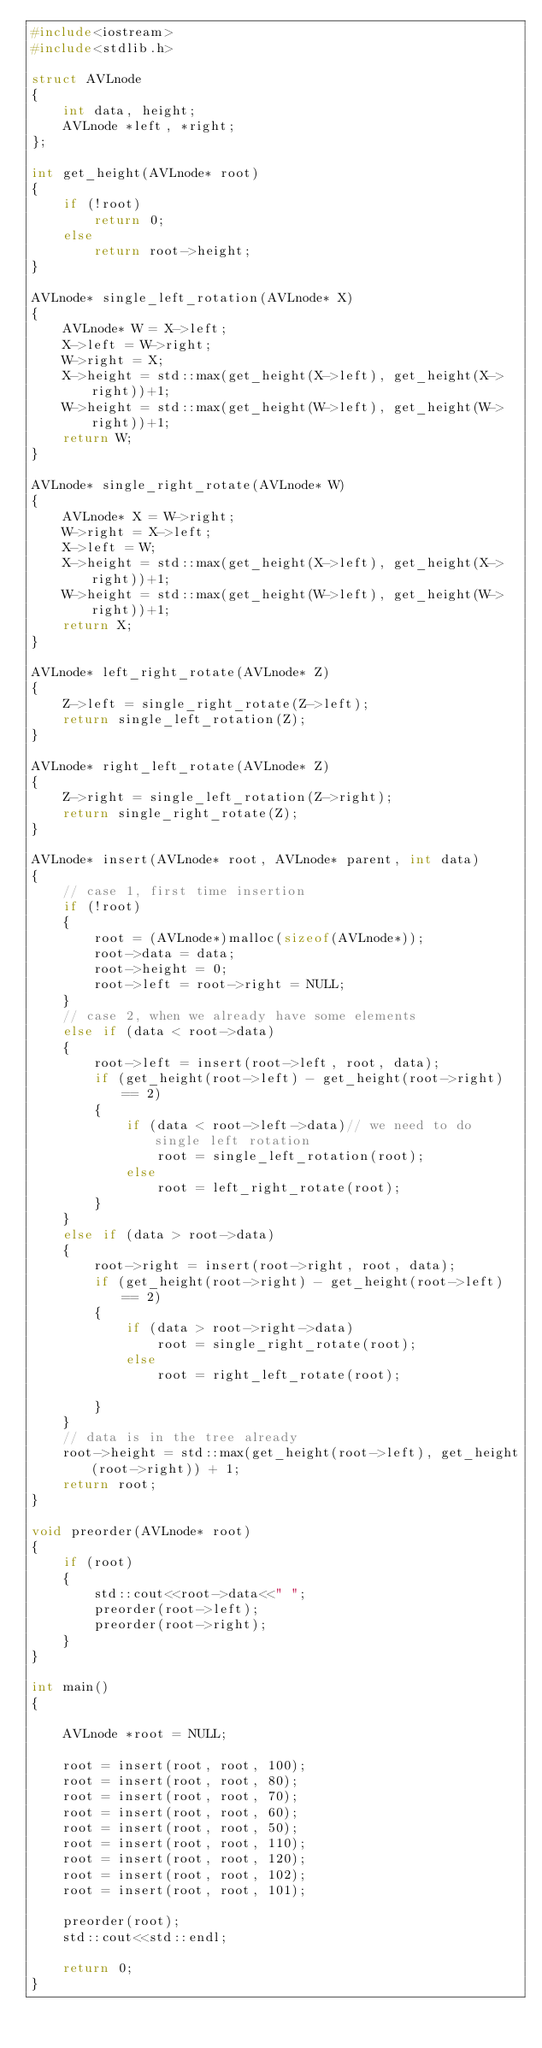Convert code to text. <code><loc_0><loc_0><loc_500><loc_500><_C++_>#include<iostream>
#include<stdlib.h>

struct AVLnode
{
    int data, height;
    AVLnode *left, *right;
};

int get_height(AVLnode* root)
{
    if (!root)
        return 0;
    else
        return root->height;
}

AVLnode* single_left_rotation(AVLnode* X)
{
    AVLnode* W = X->left;
    X->left = W->right;
    W->right = X;
    X->height = std::max(get_height(X->left), get_height(X->right))+1;
    W->height = std::max(get_height(W->left), get_height(W->right))+1;
    return W;
}

AVLnode* single_right_rotate(AVLnode* W)
{
    AVLnode* X = W->right;
    W->right = X->left;
    X->left = W;
    X->height = std::max(get_height(X->left), get_height(X->right))+1;
    W->height = std::max(get_height(W->left), get_height(W->right))+1;
    return X;
}

AVLnode* left_right_rotate(AVLnode* Z)
{
    Z->left = single_right_rotate(Z->left);
    return single_left_rotation(Z);
}

AVLnode* right_left_rotate(AVLnode* Z)
{
    Z->right = single_left_rotation(Z->right);
    return single_right_rotate(Z);
}

AVLnode* insert(AVLnode* root, AVLnode* parent, int data)
{
    // case 1, first time insertion
    if (!root)
    {
        root = (AVLnode*)malloc(sizeof(AVLnode*));
        root->data = data;
        root->height = 0;
        root->left = root->right = NULL;
    }
    // case 2, when we already have some elements
    else if (data < root->data)
    {
        root->left = insert(root->left, root, data);
        if (get_height(root->left) - get_height(root->right) == 2)
        {
            if (data < root->left->data)// we need to do single left rotation
                root = single_left_rotation(root);
            else
                root = left_right_rotate(root);
        }
    }
    else if (data > root->data)
    {
        root->right = insert(root->right, root, data);
        if (get_height(root->right) - get_height(root->left) == 2)
        {
            if (data > root->right->data)
                root = single_right_rotate(root);
            else
                root = right_left_rotate(root);

        }
    }
    // data is in the tree already
    root->height = std::max(get_height(root->left), get_height(root->right)) + 1;
    return root;
}

void preorder(AVLnode* root)
{
    if (root)
    {
        std::cout<<root->data<<" ";
        preorder(root->left);
        preorder(root->right);
    }
}

int main()
{

    AVLnode *root = NULL;

    root = insert(root, root, 100);
    root = insert(root, root, 80);
    root = insert(root, root, 70);
    root = insert(root, root, 60);
    root = insert(root, root, 50);
    root = insert(root, root, 110);
    root = insert(root, root, 120);
    root = insert(root, root, 102);
    root = insert(root, root, 101);

    preorder(root);
    std::cout<<std::endl;

    return 0;
}
</code> 